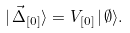<formula> <loc_0><loc_0><loc_500><loc_500>| \, \vec { \Delta } _ { [ 0 ] } \rangle = V _ { [ 0 ] } \, | \, \emptyset \rangle .</formula> 